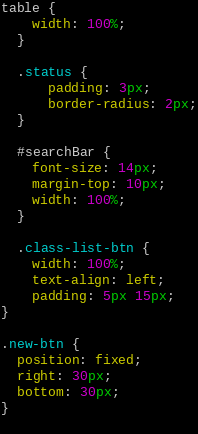Convert code to text. <code><loc_0><loc_0><loc_500><loc_500><_CSS_>
table {
    width: 100%;
  }

  .status {
      padding: 3px;
      border-radius: 2px;
  }

  #searchBar {
    font-size: 14px;
    margin-top: 10px;
    width: 100%;
  }

  .class-list-btn {
    width: 100%;
    text-align: left;
    padding: 5px 15px;
}

.new-btn {
  position: fixed;
  right: 30px;
  bottom: 30px;
}
  
</code> 